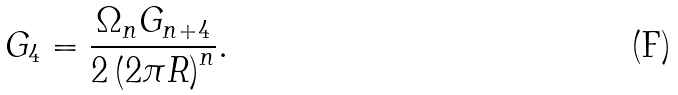<formula> <loc_0><loc_0><loc_500><loc_500>G _ { 4 } = \frac { \Omega _ { n } G _ { n + 4 } } { 2 \left ( 2 \pi R \right ) ^ { n } } .</formula> 